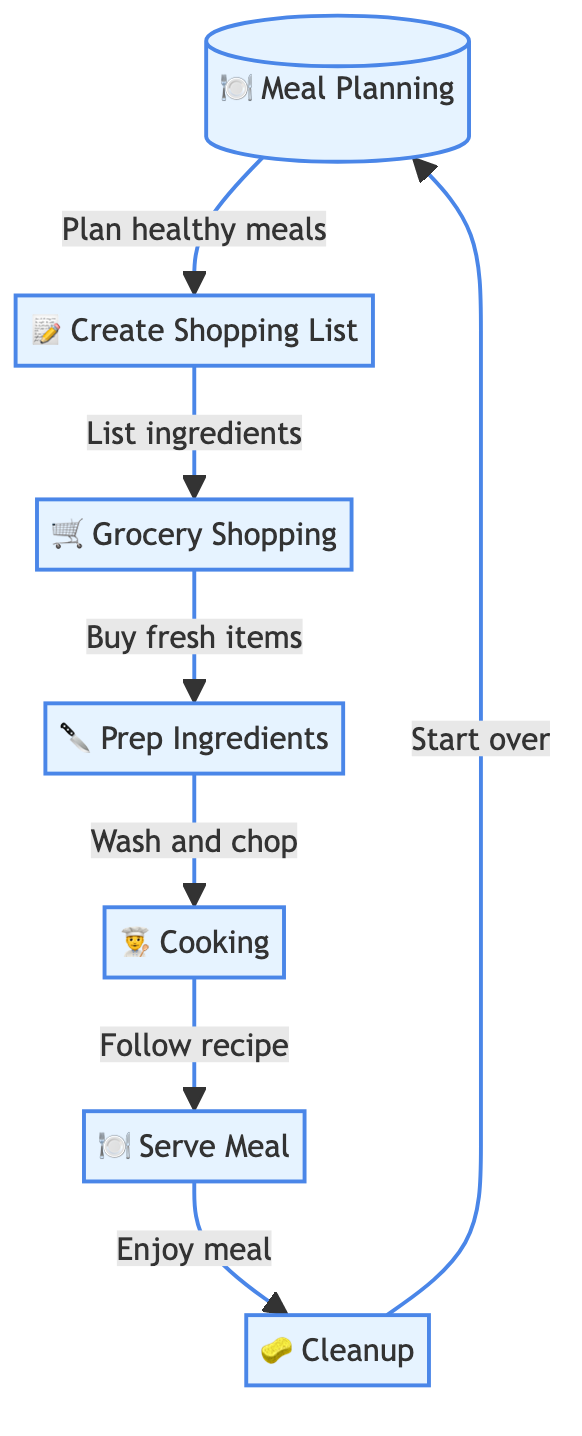What is the first step in the meal preparation flow? The flow chart starts with "Meal Planning," which is the first node in the sequence.
Answer: Meal Planning How many steps are involved in preparing a healthy meal? Counting through the steps in the flow chart, there are a total of 7 steps involved in preparing a healthy meal.
Answer: 7 What action follows "Grocery Shopping"? According to the flow chart, the action that follows "Grocery Shopping" is "Prep Ingredients."
Answer: Prep Ingredients Which step indicates the conclusion of the meal preparation process? The final step in the flow chart is "Cleanup," which is indicated as the conclusion of the meal preparation process.
Answer: Cleanup What is the last action taken before serving the meal? The last action taken before serving the meal is "Cooking," which precedes "Serve Meal" in the flow chart.
Answer: Cooking What is the relationship between "Create Shopping List" and "Grocery Shopping"? The flow chart indicates that "Create Shopping List" directly leads to "Grocery Shopping," showing that creating a shopping list is a prerequisite for grocery shopping.
Answer: Leads to How does one transition from "Serve Meal" to the beginning of the flow? The flow chart shows that after "Serve Meal," the next step is to "Cleanup," and from "Cleanup" one goes back to "Meal Planning," suggesting a cyclical process.
Answer: Start over What symbol is used to represent "Cooking" in the flow chart? The step "Cooking" is represented with the symbol "👨‍🍳" in the flow chart.
Answer: 👨‍🍳 